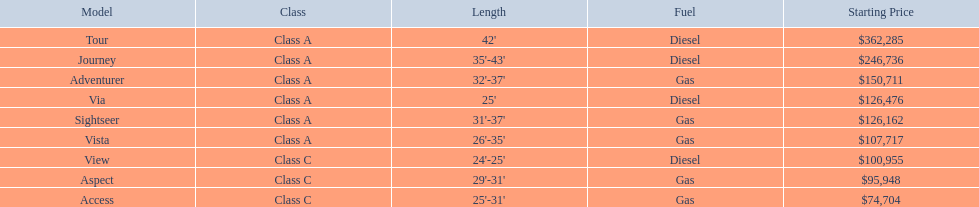What is the highest price of a winnebago model? $362,285. What is the name of the vehicle with this price? Tour. Which of the listed models run on diesel fuel? Tour, Journey, Via, View. Out of those models, which ones are classified as class a? Tour, Journey, Via. Which ones have a length of more than 35 feet? Tour, Journey. Between the two models, which one is pricier? Tour. 